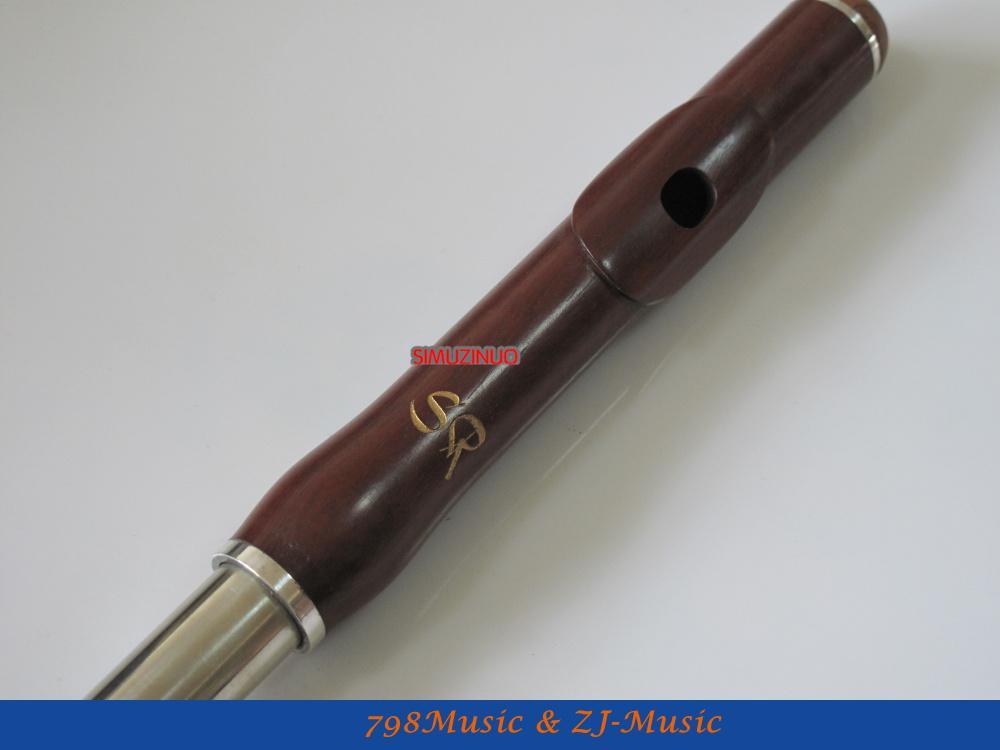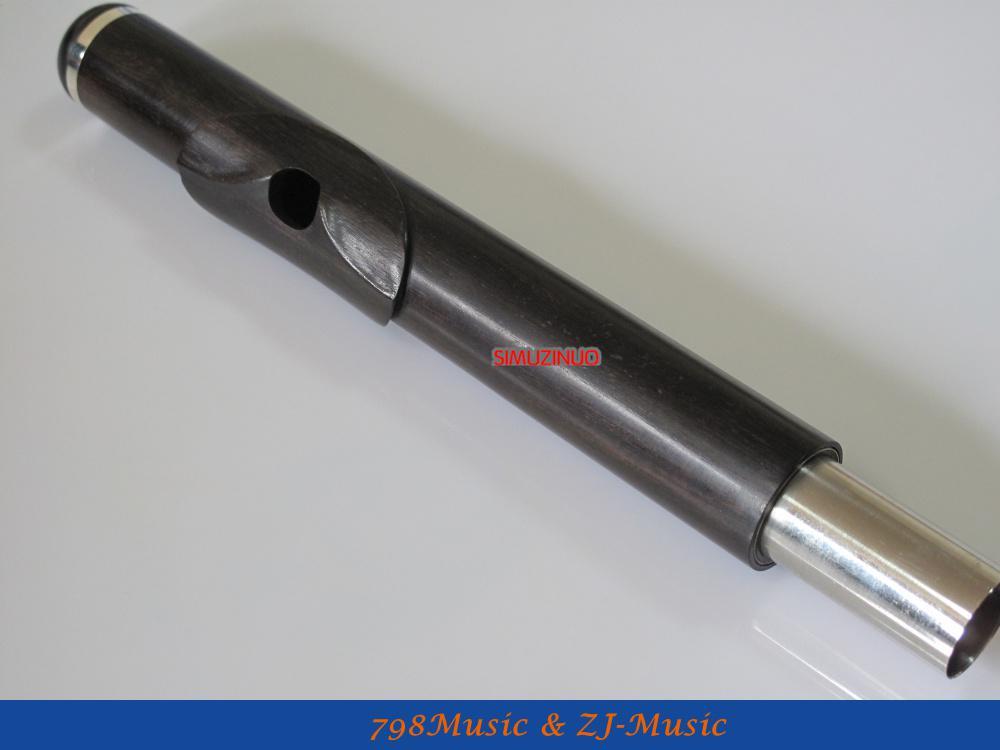The first image is the image on the left, the second image is the image on the right. Analyze the images presented: Is the assertion "The combined images include one closed instrument case and three flute parts." valid? Answer yes or no. No. The first image is the image on the left, the second image is the image on the right. For the images shown, is this caption "In at least one image there is a single close flute case sitting on the ground." true? Answer yes or no. No. 